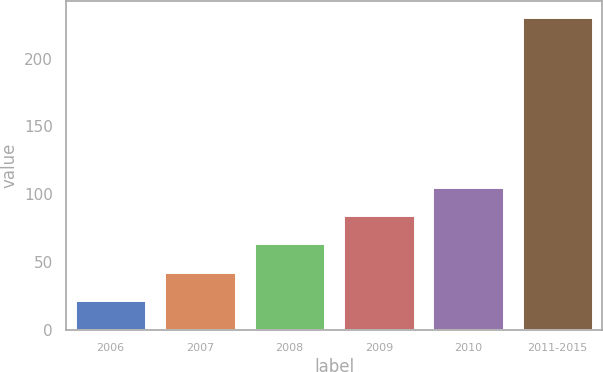<chart> <loc_0><loc_0><loc_500><loc_500><bar_chart><fcel>2006<fcel>2007<fcel>2008<fcel>2009<fcel>2010<fcel>2011-2015<nl><fcel>22<fcel>42.9<fcel>63.8<fcel>84.7<fcel>105.6<fcel>231<nl></chart> 